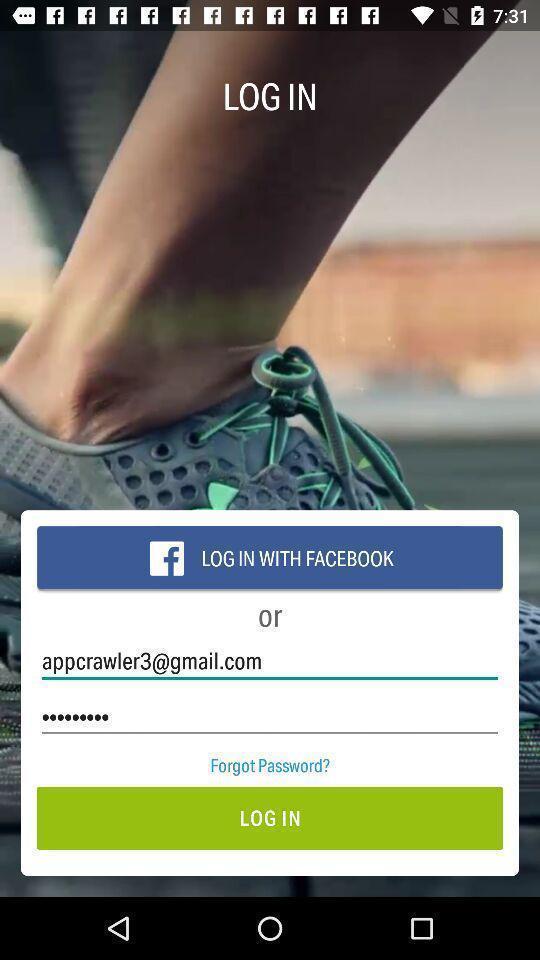Describe the visual elements of this screenshot. Login page to get the access from application. 